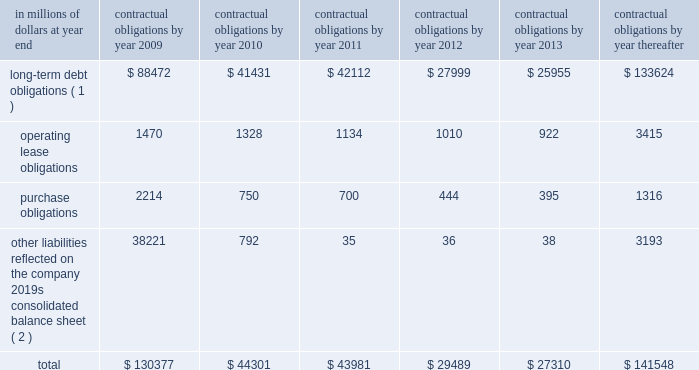Contractual obligations the table includes aggregated information about citigroup 2019s contractual obligations that impact its short- and long-term liquidity and capital needs .
The table includes information about payments due under specified contractual obligations , aggregated by type of contractual obligation .
It includes the maturity profile of the company 2019s consolidated long-term debt , operating leases and other long-term liabilities .
The company 2019s capital lease obligations are included in purchase obligations in the table .
Citigroup 2019s contractual obligations include purchase obligations that are enforceable and legally binding for the company .
For the purposes of the table below , purchase obligations are included through the termination date of the respective agreements , even if the contract is renewable .
Many of the purchase agreements for goods or services include clauses that would allow the company to cancel the agreement with specified notice ; however , that impact is not included in the table ( unless citigroup has already notified the counterparty of its intention to terminate the agreement ) .
Other liabilities reflected on the company 2019s consolidated balance sheet include obligations for goods and services that have already been received , litigation settlements , uncertain tax positions , as well as other long-term liabilities that have been incurred and will ultimately be paid in cash .
Excluded from the table are obligations that are generally short term in nature , including deposit liabilities and securities sold under agreements to repurchase .
The table also excludes certain insurance and investment contracts subject to mortality and morbidity risks or without defined maturities , such that the timing of payments and withdrawals is uncertain .
The liabilities related to these insurance and investment contracts are included on the consolidated balance sheet as insurance policy and claims reserves , contractholder funds , and separate and variable accounts .
Citigroup 2019s funding policy for pension plans is generally to fund to the minimum amounts required by the applicable laws and regulations .
At december 31 , 2008 , there were no minimum required contributions , and no contributions are currently planned for the u.s .
Pension plans .
Accordingly , no amounts have been included in the table below for future contributions to the u.s .
Pension plans .
For the non-u.s .
Plans , discretionary contributions in 2009 are anticipated to be approximately $ 167 million and this amount has been included in purchase obligations in the table below .
The estimated pension plan contributions are subject to change , since contribution decisions are affected by various factors , such as market performance , regulatory and legal requirements , and management 2019s ability to change funding policy .
For additional information regarding the company 2019s retirement benefit obligations , see note 9 to the consolidated financial statements on page 144. .
( 1 ) for additional information about long-term debt and trust preferred securities , see note 20 to the consolidated financial statements on page 169 .
( 2 ) relates primarily to accounts payable and accrued expenses included in other liabilities in the company 2019s consolidated balance sheet .
Also included are various litigation settlements. .
What percentage of total contractual obligations due in 2009 are comprised of long-term debt obligations? 
Computations: (88472 / 130377)
Answer: 0.67859. 